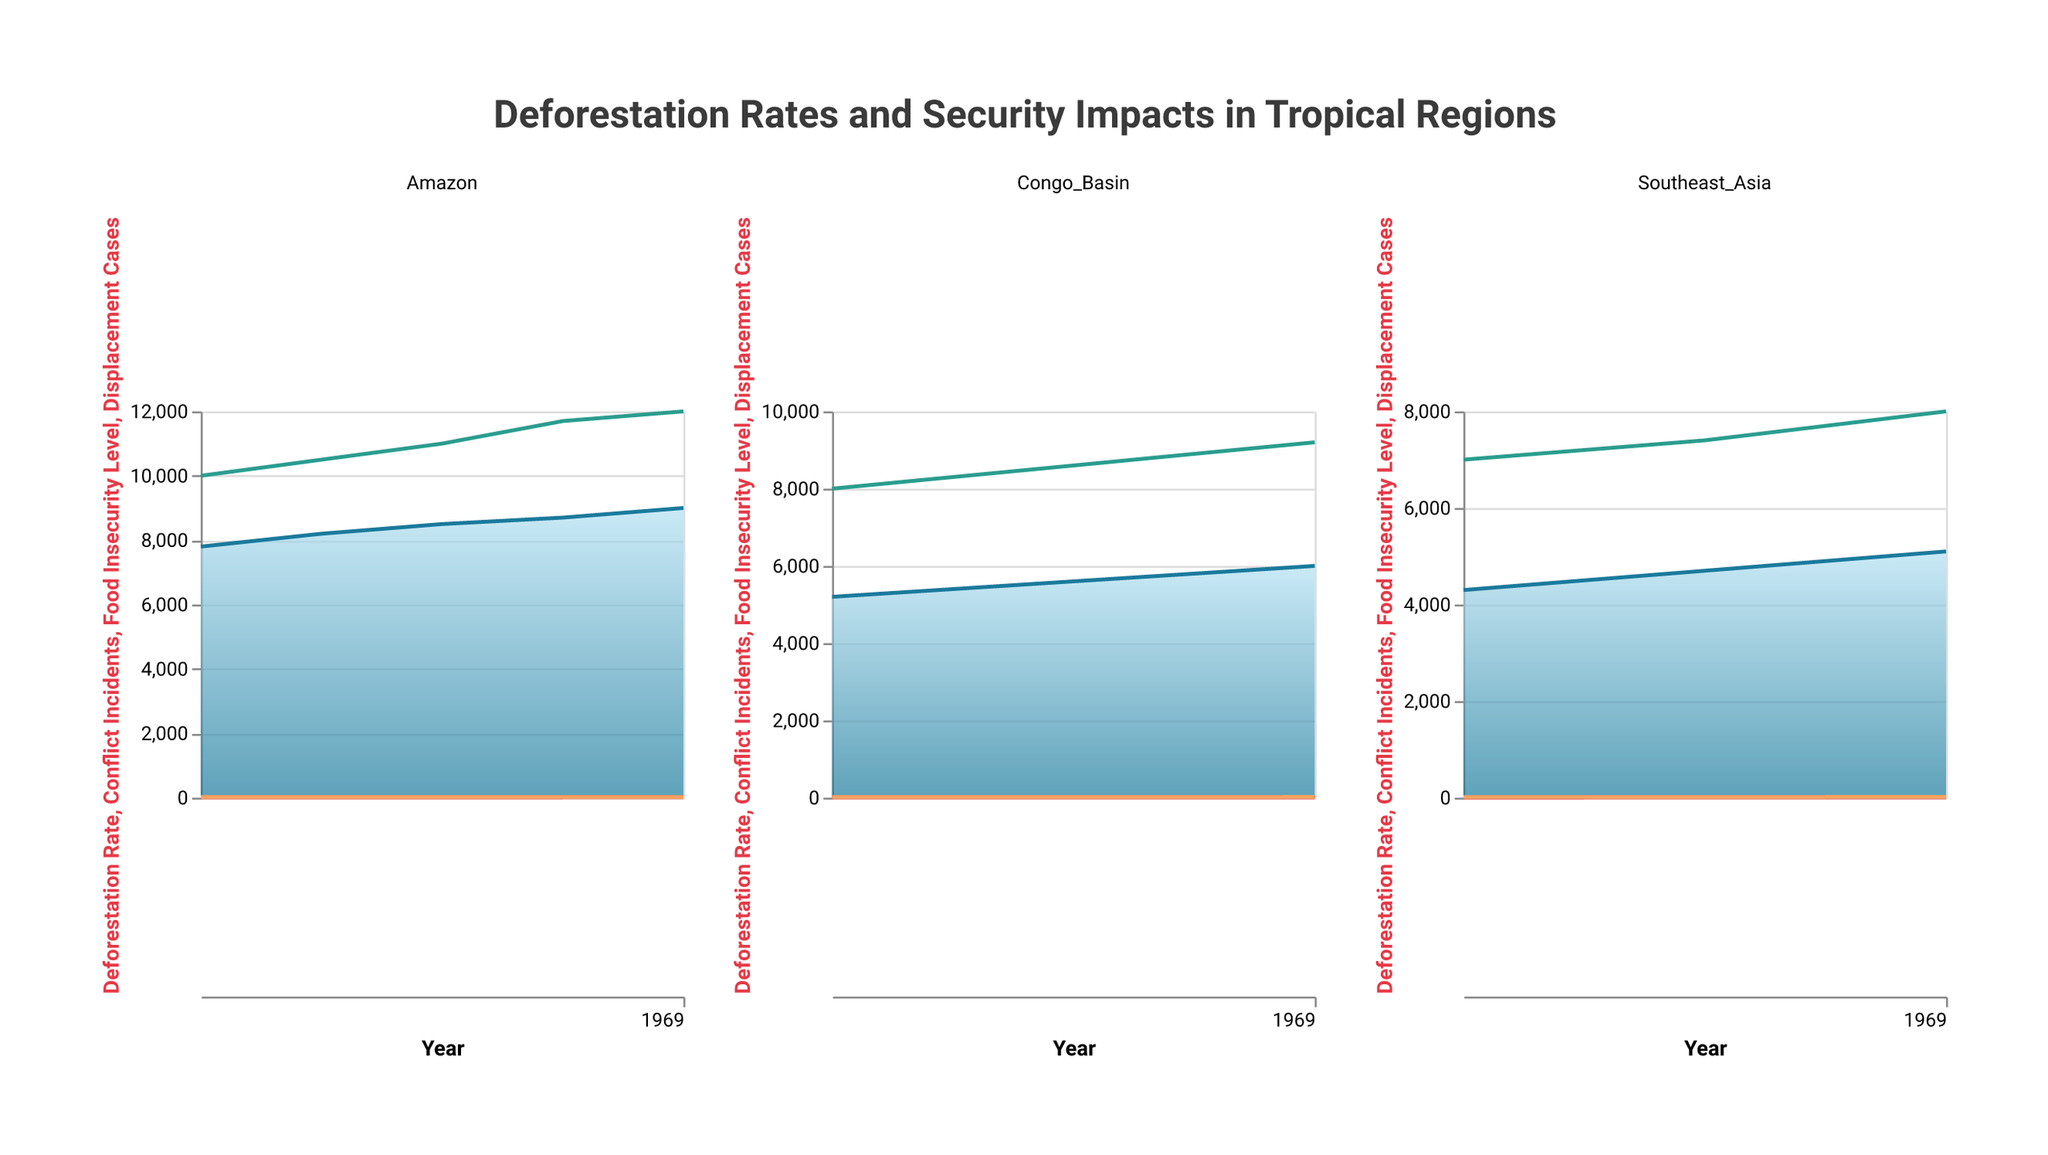What is the deforestation rate in the Amazon region in 2019? The deforestation rate can be found in the area chart segment for the Amazon region for the year 2019.
Answer: 9000 How did the number of conflict incidents change in the Congo Basin from 2015 to 2019? Look at the line chart representing Conflict Incidents in the Congo Basin and compare the values from 2015 to 2019.
Answer: Increased from 8 to 12 Compare the food insecurity levels in 2017 between the Southeast Asia and Amazon regions. Which is higher? Review the line charts representing Food Insecurity Levels for both Southeast Asia and Amazon regions for the year 2017.
Answer: Amazon What is the trend of displacement cases in the Amazon region from 2015 to 2019? Examine the line chart representing Displacement Cases in the Amazon region over the years 2015 to 2019.
Answer: Increasing Which region had the highest deforestation rate in 2015? Compare the initial values for deforestation rates across the Amazon, Congo Basin, and Southeast Asia regions.
Answer: Amazon What is the difference in displacement cases between Southeast Asia and the Congo Basin in 2019? Identify the displacement cases for Southeast Asia and the Congo Basin in 2019 and subtract one from the other.
Answer: 8000 - 9200 = -1200 In which year did the deforestation rate in the Congo Basin exceed 5800? Check the values in the area chart for the Congo Basin to find the first year the deforestation rate surpasses 5800.
Answer: 2019 Compare the trends of food insecurity levels in the Amazon and Southeast Asia regions. Are they moving in the same or different directions? Examine the line charts for Food Insecurity Levels in both regions over the given years to determine if the trends are similar or dissimilar.
Answer: Similar What's the average deforestation rate in Southeast Asia from 2015 to 2019? Sum up the deforestation rates for Southeast Asia across the years 2015, 2016, 2017, 2018, and 2019, then divide by the number of years. Calculation: (4300 + 4500 + 4700 + 4900 + 5100)/5 = 4700
Answer: 4700 How does the rate of conflict incidents in the Amazon compare to that in Southeast Asia in 2018? Compare the values of Conflict Incidents in the line charts for both the Amazon and Southeast Asia in 2018.
Answer: Amazon had more (15 vs 8) 